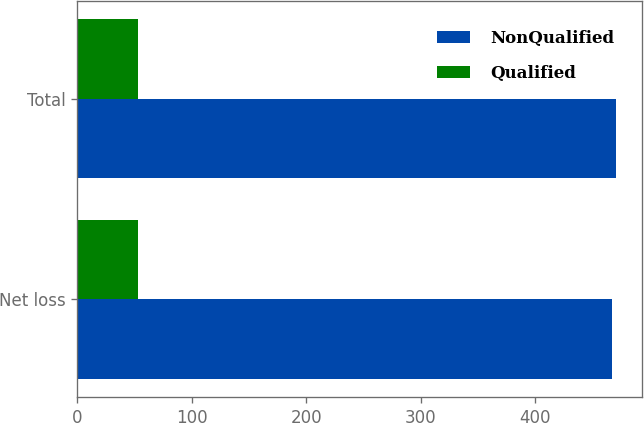Convert chart. <chart><loc_0><loc_0><loc_500><loc_500><stacked_bar_chart><ecel><fcel>Net loss<fcel>Total<nl><fcel>NonQualified<fcel>467<fcel>470<nl><fcel>Qualified<fcel>53<fcel>53<nl></chart> 